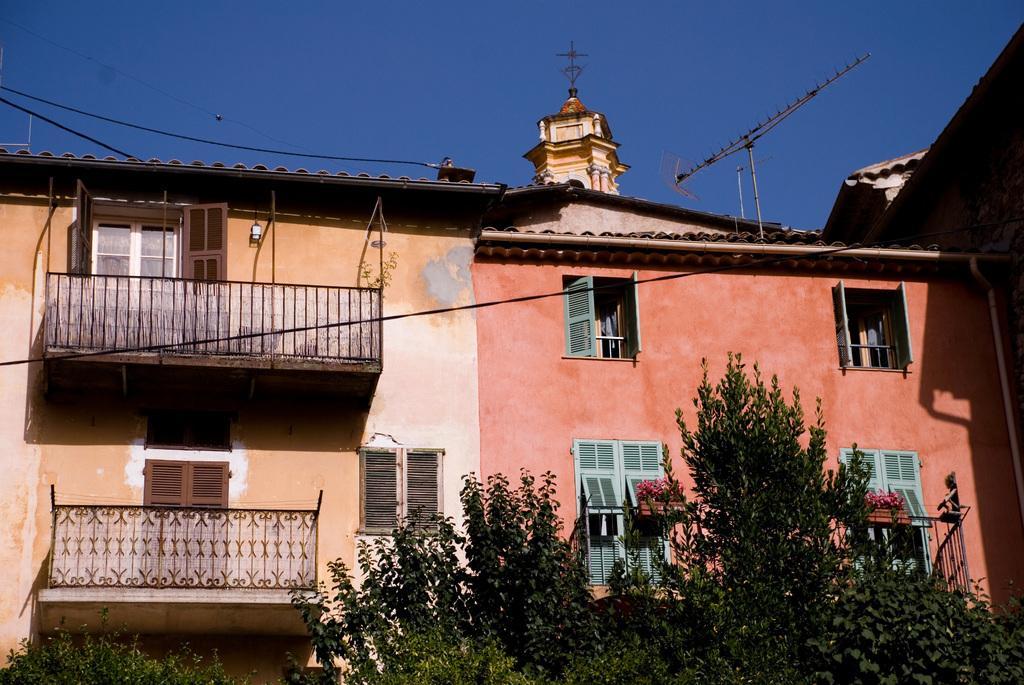Could you give a brief overview of what you see in this image? In this picture we can see trees, building, windows, poles, wires and railing. In the background of the image we can see sky in blue color. 